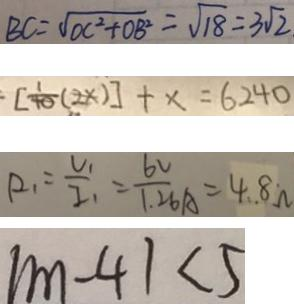Convert formula to latex. <formula><loc_0><loc_0><loc_500><loc_500>B C = \sqrt { O C ^ { 2 } + O B ^ { 2 } } = \sqrt { 1 8 } = 3 \sqrt { 2 } 
 . [ \frac { 1 } { 4 0 } ( 2 x ) ] + x = 6 2 4 0 
 R _ { 1 } = \frac { V _ { 1 } } { I _ { 1 } } = \frac { 6 V } { 1 . 2 6 A } = 4 . 8 \Omega 
 \vert m - 4 \vert < 5</formula> 